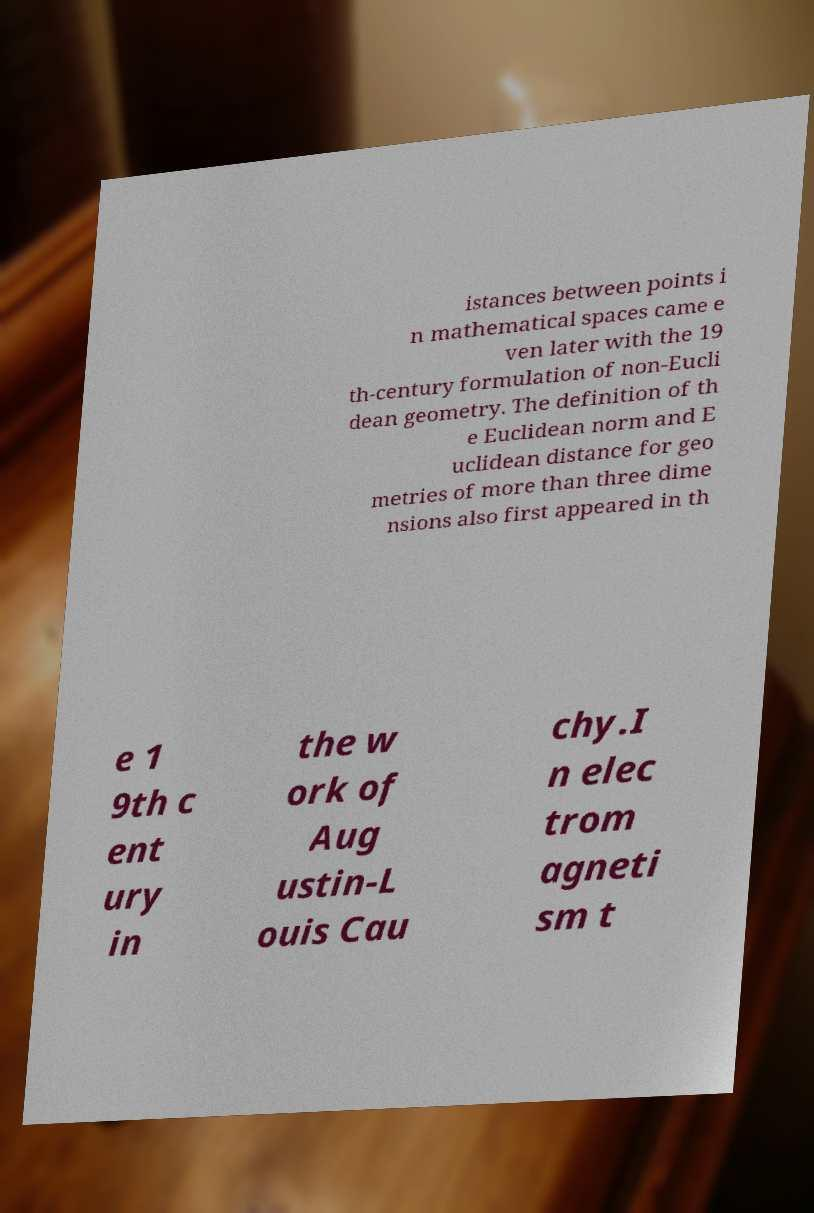What messages or text are displayed in this image? I need them in a readable, typed format. istances between points i n mathematical spaces came e ven later with the 19 th-century formulation of non-Eucli dean geometry. The definition of th e Euclidean norm and E uclidean distance for geo metries of more than three dime nsions also first appeared in th e 1 9th c ent ury in the w ork of Aug ustin-L ouis Cau chy.I n elec trom agneti sm t 